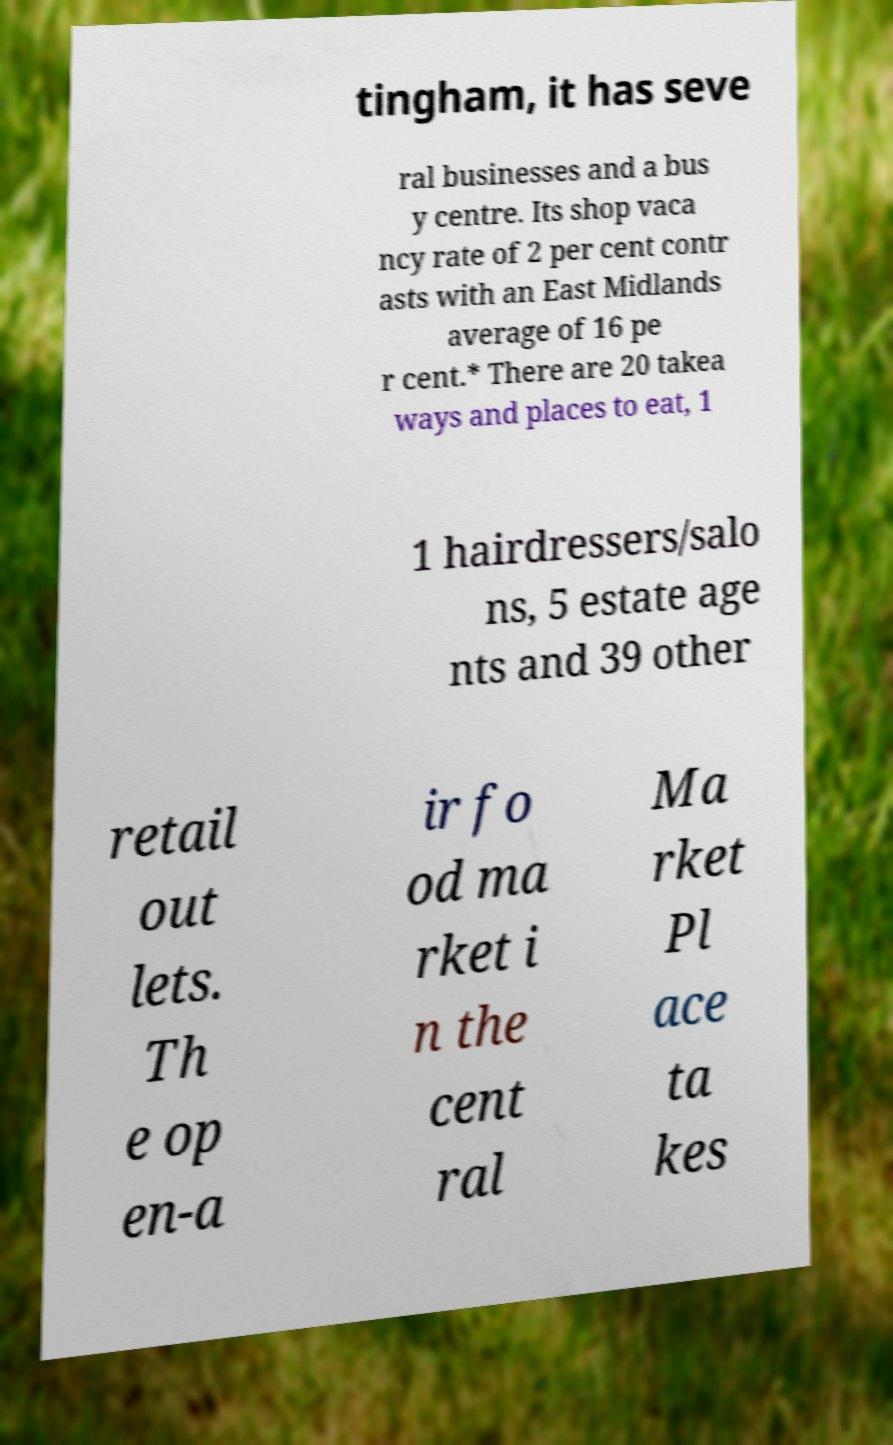Could you assist in decoding the text presented in this image and type it out clearly? tingham, it has seve ral businesses and a bus y centre. Its shop vaca ncy rate of 2 per cent contr asts with an East Midlands average of 16 pe r cent.* There are 20 takea ways and places to eat, 1 1 hairdressers/salo ns, 5 estate age nts and 39 other retail out lets. Th e op en-a ir fo od ma rket i n the cent ral Ma rket Pl ace ta kes 